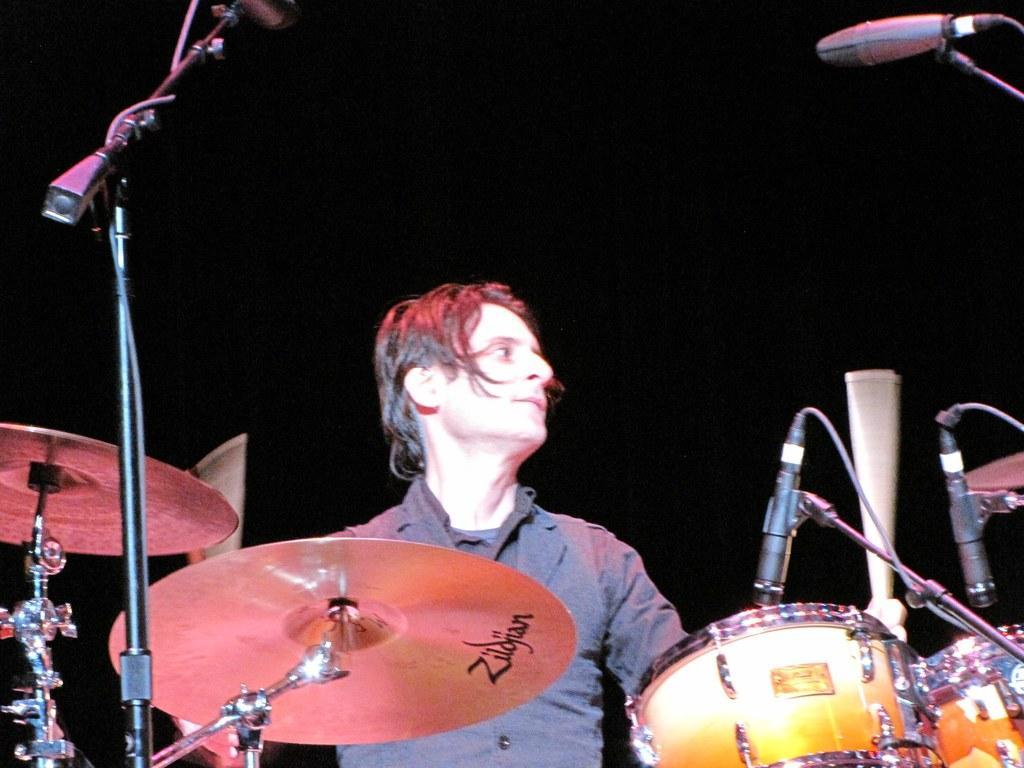In one or two sentences, can you explain what this image depicts? In this image I can see the person with the grey color dress. In-front of the person I can see the musical instruments and the mics. I can see the black background. 